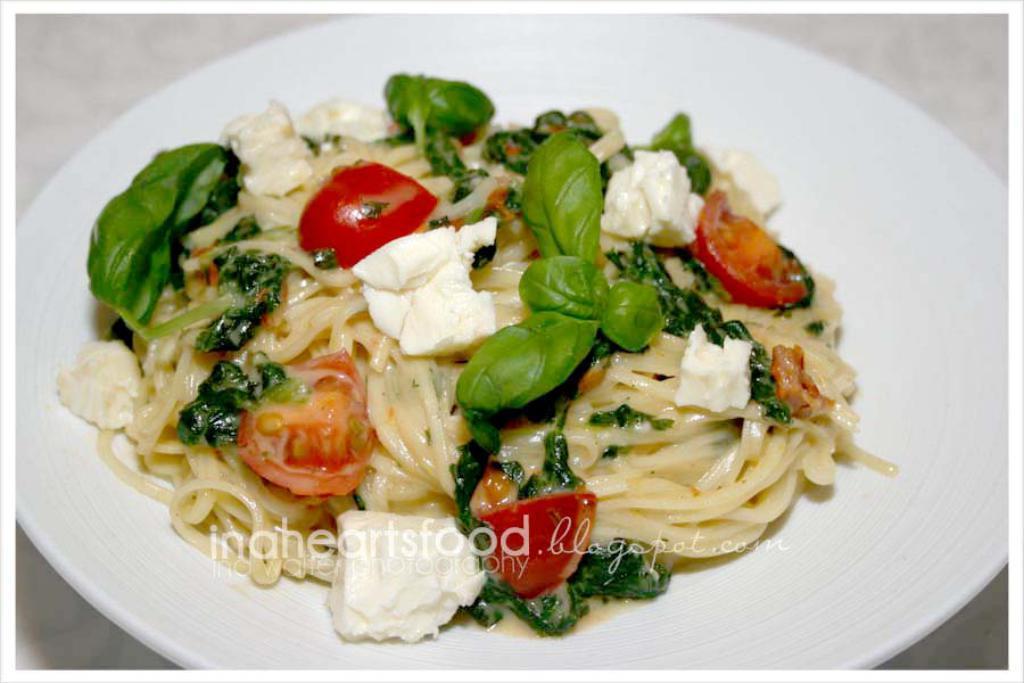Please provide a concise description of this image. In this picture I can see there is a plate and there is some food on the plate, with green leafy vegetables garnished, it is placed on the white surface. There is a watermark in the center of the image. 